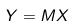Convert formula to latex. <formula><loc_0><loc_0><loc_500><loc_500>Y = M X</formula> 